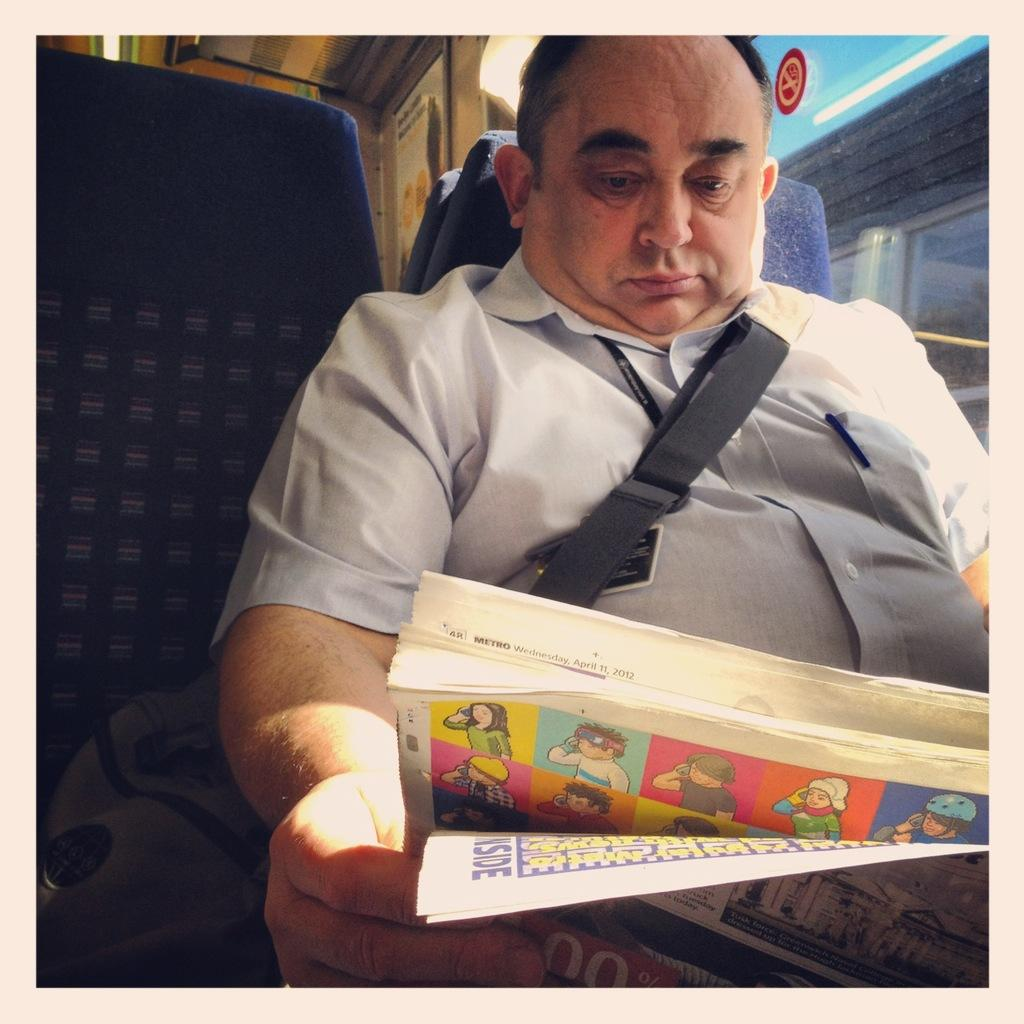Who is present in the image? There is a man in the image. Where is the man located? The man is sitting inside a bus. What is the man doing in the image? The man is reading a newspaper. What can be seen behind the man? The man is in front of a window. What type of cakes is the man baking in the image? There is no indication in the image that the man is baking cakes, as he is reading a newspaper. 